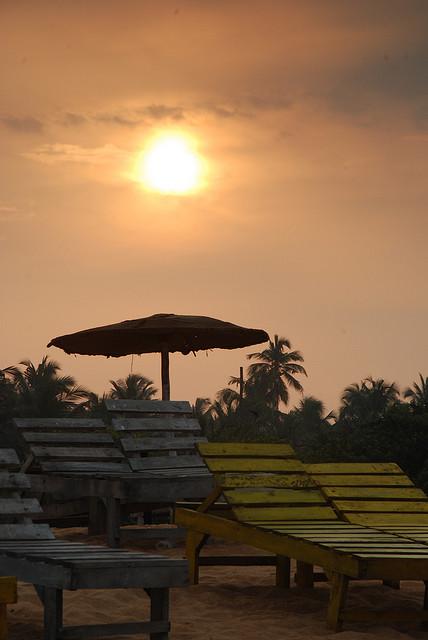Who many persons do you see under the umbrella?
Quick response, please. 0. What is under the umbrella?
Write a very short answer. Chair. What are the benches used for?
Short answer required. Sunbathing. How can you tell this is a warm place?
Answer briefly. Palm trees. Is the sun out?
Concise answer only. Yes. Is this picture of the city?
Answer briefly. No. 